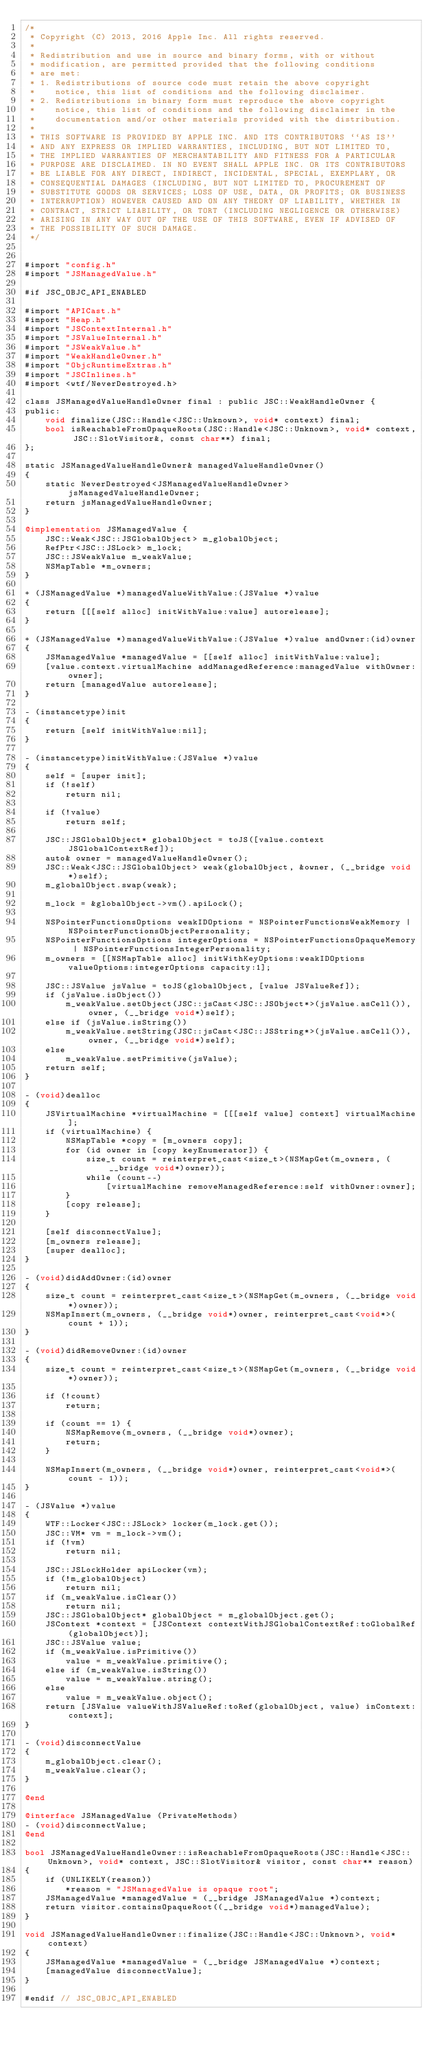<code> <loc_0><loc_0><loc_500><loc_500><_ObjectiveC_>/*
 * Copyright (C) 2013, 2016 Apple Inc. All rights reserved.
 *
 * Redistribution and use in source and binary forms, with or without
 * modification, are permitted provided that the following conditions
 * are met:
 * 1. Redistributions of source code must retain the above copyright
 *    notice, this list of conditions and the following disclaimer.
 * 2. Redistributions in binary form must reproduce the above copyright
 *    notice, this list of conditions and the following disclaimer in the
 *    documentation and/or other materials provided with the distribution.
 *
 * THIS SOFTWARE IS PROVIDED BY APPLE INC. AND ITS CONTRIBUTORS ``AS IS''
 * AND ANY EXPRESS OR IMPLIED WARRANTIES, INCLUDING, BUT NOT LIMITED TO,
 * THE IMPLIED WARRANTIES OF MERCHANTABILITY AND FITNESS FOR A PARTICULAR
 * PURPOSE ARE DISCLAIMED. IN NO EVENT SHALL APPLE INC. OR ITS CONTRIBUTORS
 * BE LIABLE FOR ANY DIRECT, INDIRECT, INCIDENTAL, SPECIAL, EXEMPLARY, OR
 * CONSEQUENTIAL DAMAGES (INCLUDING, BUT NOT LIMITED TO, PROCUREMENT OF
 * SUBSTITUTE GOODS OR SERVICES; LOSS OF USE, DATA, OR PROFITS; OR BUSINESS
 * INTERRUPTION) HOWEVER CAUSED AND ON ANY THEORY OF LIABILITY, WHETHER IN
 * CONTRACT, STRICT LIABILITY, OR TORT (INCLUDING NEGLIGENCE OR OTHERWISE)
 * ARISING IN ANY WAY OUT OF THE USE OF THIS SOFTWARE, EVEN IF ADVISED OF
 * THE POSSIBILITY OF SUCH DAMAGE.
 */


#import "config.h"
#import "JSManagedValue.h"

#if JSC_OBJC_API_ENABLED

#import "APICast.h"
#import "Heap.h"
#import "JSContextInternal.h"
#import "JSValueInternal.h"
#import "JSWeakValue.h"
#import "WeakHandleOwner.h"
#import "ObjcRuntimeExtras.h"
#import "JSCInlines.h"
#import <wtf/NeverDestroyed.h>

class JSManagedValueHandleOwner final : public JSC::WeakHandleOwner {
public:
    void finalize(JSC::Handle<JSC::Unknown>, void* context) final;
    bool isReachableFromOpaqueRoots(JSC::Handle<JSC::Unknown>, void* context, JSC::SlotVisitor&, const char**) final;
};

static JSManagedValueHandleOwner& managedValueHandleOwner()
{
    static NeverDestroyed<JSManagedValueHandleOwner> jsManagedValueHandleOwner;
    return jsManagedValueHandleOwner;
}

@implementation JSManagedValue {
    JSC::Weak<JSC::JSGlobalObject> m_globalObject;
    RefPtr<JSC::JSLock> m_lock;
    JSC::JSWeakValue m_weakValue;
    NSMapTable *m_owners;
}

+ (JSManagedValue *)managedValueWithValue:(JSValue *)value
{
    return [[[self alloc] initWithValue:value] autorelease];
}

+ (JSManagedValue *)managedValueWithValue:(JSValue *)value andOwner:(id)owner
{
    JSManagedValue *managedValue = [[self alloc] initWithValue:value];
    [value.context.virtualMachine addManagedReference:managedValue withOwner:owner];
    return [managedValue autorelease];
}

- (instancetype)init
{
    return [self initWithValue:nil];
}

- (instancetype)initWithValue:(JSValue *)value
{
    self = [super init];
    if (!self)
        return nil;
    
    if (!value)
        return self;

    JSC::JSGlobalObject* globalObject = toJS([value.context JSGlobalContextRef]);
    auto& owner = managedValueHandleOwner();
    JSC::Weak<JSC::JSGlobalObject> weak(globalObject, &owner, (__bridge void*)self);
    m_globalObject.swap(weak);

    m_lock = &globalObject->vm().apiLock();

    NSPointerFunctionsOptions weakIDOptions = NSPointerFunctionsWeakMemory | NSPointerFunctionsObjectPersonality;
    NSPointerFunctionsOptions integerOptions = NSPointerFunctionsOpaqueMemory | NSPointerFunctionsIntegerPersonality;
    m_owners = [[NSMapTable alloc] initWithKeyOptions:weakIDOptions valueOptions:integerOptions capacity:1];

    JSC::JSValue jsValue = toJS(globalObject, [value JSValueRef]);
    if (jsValue.isObject())
        m_weakValue.setObject(JSC::jsCast<JSC::JSObject*>(jsValue.asCell()), owner, (__bridge void*)self);
    else if (jsValue.isString())
        m_weakValue.setString(JSC::jsCast<JSC::JSString*>(jsValue.asCell()), owner, (__bridge void*)self);
    else
        m_weakValue.setPrimitive(jsValue);
    return self;
}

- (void)dealloc
{
    JSVirtualMachine *virtualMachine = [[[self value] context] virtualMachine];
    if (virtualMachine) {
        NSMapTable *copy = [m_owners copy];
        for (id owner in [copy keyEnumerator]) {
            size_t count = reinterpret_cast<size_t>(NSMapGet(m_owners, (__bridge void*)owner));
            while (count--)
                [virtualMachine removeManagedReference:self withOwner:owner];
        }
        [copy release];
    }

    [self disconnectValue];
    [m_owners release];
    [super dealloc];
}

- (void)didAddOwner:(id)owner
{
    size_t count = reinterpret_cast<size_t>(NSMapGet(m_owners, (__bridge void*)owner));
    NSMapInsert(m_owners, (__bridge void*)owner, reinterpret_cast<void*>(count + 1));
}

- (void)didRemoveOwner:(id)owner
{
    size_t count = reinterpret_cast<size_t>(NSMapGet(m_owners, (__bridge void*)owner));

    if (!count)
        return;

    if (count == 1) {
        NSMapRemove(m_owners, (__bridge void*)owner);
        return;
    }

    NSMapInsert(m_owners, (__bridge void*)owner, reinterpret_cast<void*>(count - 1));
}

- (JSValue *)value
{
    WTF::Locker<JSC::JSLock> locker(m_lock.get());
    JSC::VM* vm = m_lock->vm();
    if (!vm)
        return nil;

    JSC::JSLockHolder apiLocker(vm);
    if (!m_globalObject)
        return nil;
    if (m_weakValue.isClear())
        return nil;
    JSC::JSGlobalObject* globalObject = m_globalObject.get();
    JSContext *context = [JSContext contextWithJSGlobalContextRef:toGlobalRef(globalObject)];
    JSC::JSValue value;
    if (m_weakValue.isPrimitive())
        value = m_weakValue.primitive();
    else if (m_weakValue.isString())
        value = m_weakValue.string();
    else
        value = m_weakValue.object();
    return [JSValue valueWithJSValueRef:toRef(globalObject, value) inContext:context];
}

- (void)disconnectValue
{
    m_globalObject.clear();
    m_weakValue.clear();
}

@end

@interface JSManagedValue (PrivateMethods)
- (void)disconnectValue;
@end

bool JSManagedValueHandleOwner::isReachableFromOpaqueRoots(JSC::Handle<JSC::Unknown>, void* context, JSC::SlotVisitor& visitor, const char** reason)
{
    if (UNLIKELY(reason))
        *reason = "JSManagedValue is opaque root";
    JSManagedValue *managedValue = (__bridge JSManagedValue *)context;
    return visitor.containsOpaqueRoot((__bridge void*)managedValue);
}

void JSManagedValueHandleOwner::finalize(JSC::Handle<JSC::Unknown>, void* context)
{
    JSManagedValue *managedValue = (__bridge JSManagedValue *)context;
    [managedValue disconnectValue];
}

#endif // JSC_OBJC_API_ENABLED
</code> 